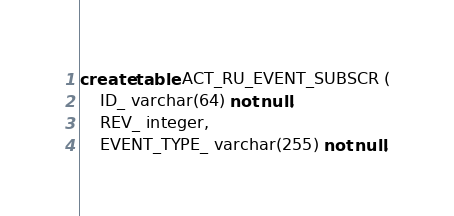Convert code to text. <code><loc_0><loc_0><loc_500><loc_500><_SQL_>create table ACT_RU_EVENT_SUBSCR (
    ID_ varchar(64) not null,
    REV_ integer,
    EVENT_TYPE_ varchar(255) not null,</code> 